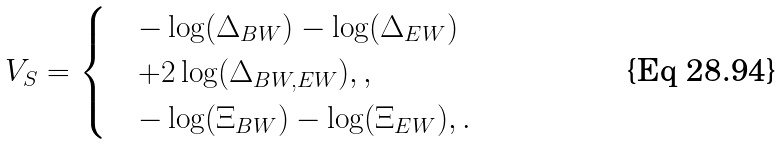<formula> <loc_0><loc_0><loc_500><loc_500>V _ { S } = \begin{cases} & - \log ( \Delta _ { B W } ) - \log ( \Delta _ { E W } ) \\ & + 2 \log ( \Delta _ { B W , E W } ) , , \\ & - \log ( \Xi _ { B W } ) - \log ( \Xi _ { E W } ) , . \end{cases}</formula> 